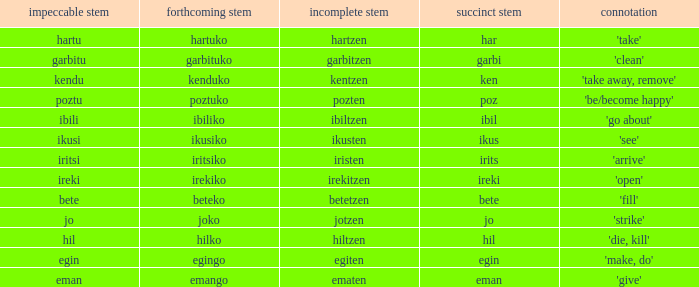What is the short stem for garbitzen? Garbi. 